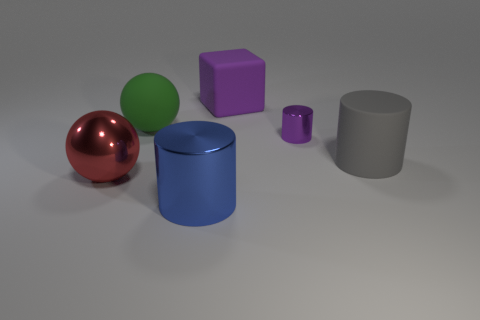What number of other things are there of the same shape as the green object?
Your answer should be very brief. 1. What is the color of the big thing that is on the left side of the large purple rubber cube and behind the tiny object?
Your answer should be compact. Green. The metallic sphere has what color?
Ensure brevity in your answer.  Red. Does the red sphere have the same material as the sphere to the right of the red thing?
Provide a succinct answer. No. What shape is the purple thing that is the same material as the green object?
Ensure brevity in your answer.  Cube. What is the color of the metallic thing that is the same size as the metal ball?
Your answer should be compact. Blue. Do the object that is in front of the red ball and the green ball have the same size?
Keep it short and to the point. Yes. Does the matte cylinder have the same color as the small metallic cylinder?
Offer a very short reply. No. What number of large green things are there?
Your response must be concise. 1. How many spheres are tiny purple metal objects or big purple objects?
Keep it short and to the point. 0. 